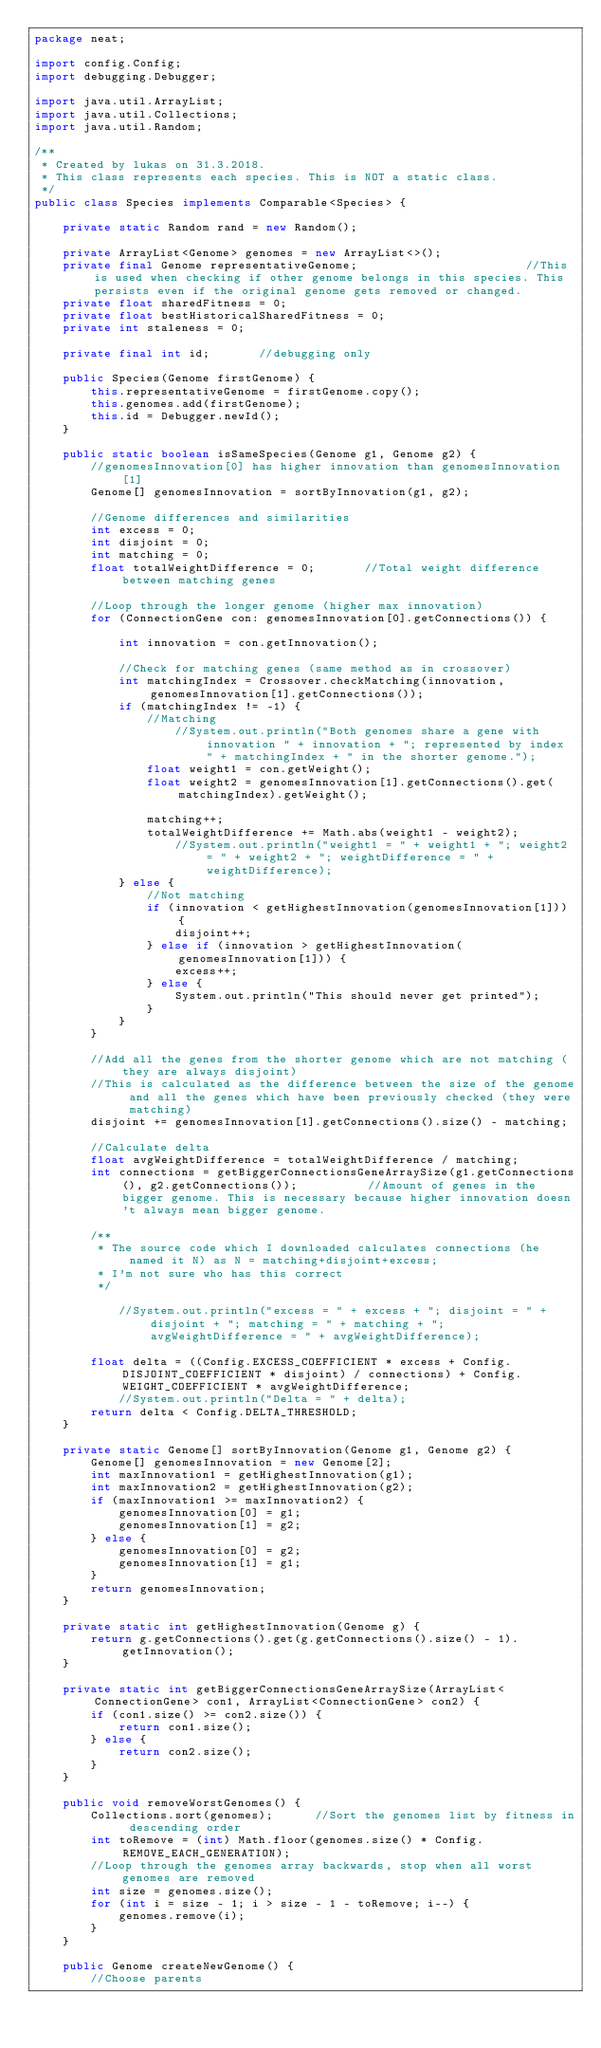Convert code to text. <code><loc_0><loc_0><loc_500><loc_500><_Java_>package neat;

import config.Config;
import debugging.Debugger;

import java.util.ArrayList;
import java.util.Collections;
import java.util.Random;

/**
 * Created by lukas on 31.3.2018.
 * This class represents each species. This is NOT a static class.
 */
public class Species implements Comparable<Species> {

    private static Random rand = new Random();

    private ArrayList<Genome> genomes = new ArrayList<>();
    private final Genome representativeGenome;                        //This is used when checking if other genome belongs in this species. This persists even if the original genome gets removed or changed.
    private float sharedFitness = 0;
    private float bestHistoricalSharedFitness = 0;
    private int staleness = 0;

    private final int id;       //debugging only

    public Species(Genome firstGenome) {
        this.representativeGenome = firstGenome.copy();
        this.genomes.add(firstGenome);
        this.id = Debugger.newId();
    }

    public static boolean isSameSpecies(Genome g1, Genome g2) {
        //genomesInnovation[0] has higher innovation than genomesInnovation[1]
        Genome[] genomesInnovation = sortByInnovation(g1, g2);

        //Genome differences and similarities
        int excess = 0;
        int disjoint = 0;
        int matching = 0;
        float totalWeightDifference = 0;       //Total weight difference between matching genes

        //Loop through the longer genome (higher max innovation)
        for (ConnectionGene con: genomesInnovation[0].getConnections()) {

            int innovation = con.getInnovation();

            //Check for matching genes (same method as in crossover)
            int matchingIndex = Crossover.checkMatching(innovation, genomesInnovation[1].getConnections());
            if (matchingIndex != -1) {
                //Matching
                    //System.out.println("Both genomes share a gene with innovation " + innovation + "; represented by index " + matchingIndex + " in the shorter genome.");
                float weight1 = con.getWeight();
                float weight2 = genomesInnovation[1].getConnections().get(matchingIndex).getWeight();

                matching++;
                totalWeightDifference += Math.abs(weight1 - weight2);
                    //System.out.println("weight1 = " + weight1 + "; weight2 = " + weight2 + "; weightDifference = " + weightDifference);
            } else {
                //Not matching
                if (innovation < getHighestInnovation(genomesInnovation[1])) {
                    disjoint++;
                } else if (innovation > getHighestInnovation(genomesInnovation[1])) {
                    excess++;
                } else {
                    System.out.println("This should never get printed");
                }
            }
        }

        //Add all the genes from the shorter genome which are not matching (they are always disjoint)
        //This is calculated as the difference between the size of the genome and all the genes which have been previously checked (they were matching)
        disjoint += genomesInnovation[1].getConnections().size() - matching;

        //Calculate delta
        float avgWeightDifference = totalWeightDifference / matching;
        int connections = getBiggerConnectionsGeneArraySize(g1.getConnections(), g2.getConnections());          //Amount of genes in the bigger genome. This is necessary because higher innovation doesn't always mean bigger genome.

        /**
         * The source code which I downloaded calculates connections (he named it N) as N = matching+disjoint+excess;
         * I'm not sure who has this correct
         */

            //System.out.println("excess = " + excess + "; disjoint = " + disjoint + "; matching = " + matching + "; avgWeightDifference = " + avgWeightDifference);

        float delta = ((Config.EXCESS_COEFFICIENT * excess + Config.DISJOINT_COEFFICIENT * disjoint) / connections) + Config.WEIGHT_COEFFICIENT * avgWeightDifference;
            //System.out.println("Delta = " + delta);
        return delta < Config.DELTA_THRESHOLD;
    }

    private static Genome[] sortByInnovation(Genome g1, Genome g2) {
        Genome[] genomesInnovation = new Genome[2];
        int maxInnovation1 = getHighestInnovation(g1);
        int maxInnovation2 = getHighestInnovation(g2);
        if (maxInnovation1 >= maxInnovation2) {
            genomesInnovation[0] = g1;
            genomesInnovation[1] = g2;
        } else {
            genomesInnovation[0] = g2;
            genomesInnovation[1] = g1;
        }
        return genomesInnovation;
    }

    private static int getHighestInnovation(Genome g) {
        return g.getConnections().get(g.getConnections().size() - 1).getInnovation();
    }

    private static int getBiggerConnectionsGeneArraySize(ArrayList<ConnectionGene> con1, ArrayList<ConnectionGene> con2) {
        if (con1.size() >= con2.size()) {
            return con1.size();
        } else {
            return con2.size();
        }
    }

    public void removeWorstGenomes() {
        Collections.sort(genomes);      //Sort the genomes list by fitness in descending order
        int toRemove = (int) Math.floor(genomes.size() * Config.REMOVE_EACH_GENERATION);
        //Loop through the genomes array backwards, stop when all worst genomes are removed
        int size = genomes.size();
        for (int i = size - 1; i > size - 1 - toRemove; i--) {
            genomes.remove(i);
        }
    }

    public Genome createNewGenome() {
        //Choose parents</code> 